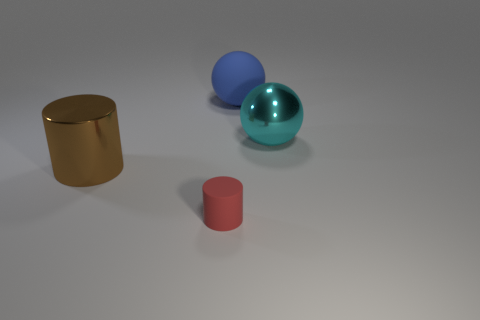What do you think the setting of this image is based on background cues? The setting seems to be quite minimalistic with a focus on the objects themselves. The background is a neutral grey with a subtle gradient, suggesting an indoor environment with simple and controlled lighting, possibly designed to emphasize the shapes and materials of the objects without adding any distractions. 